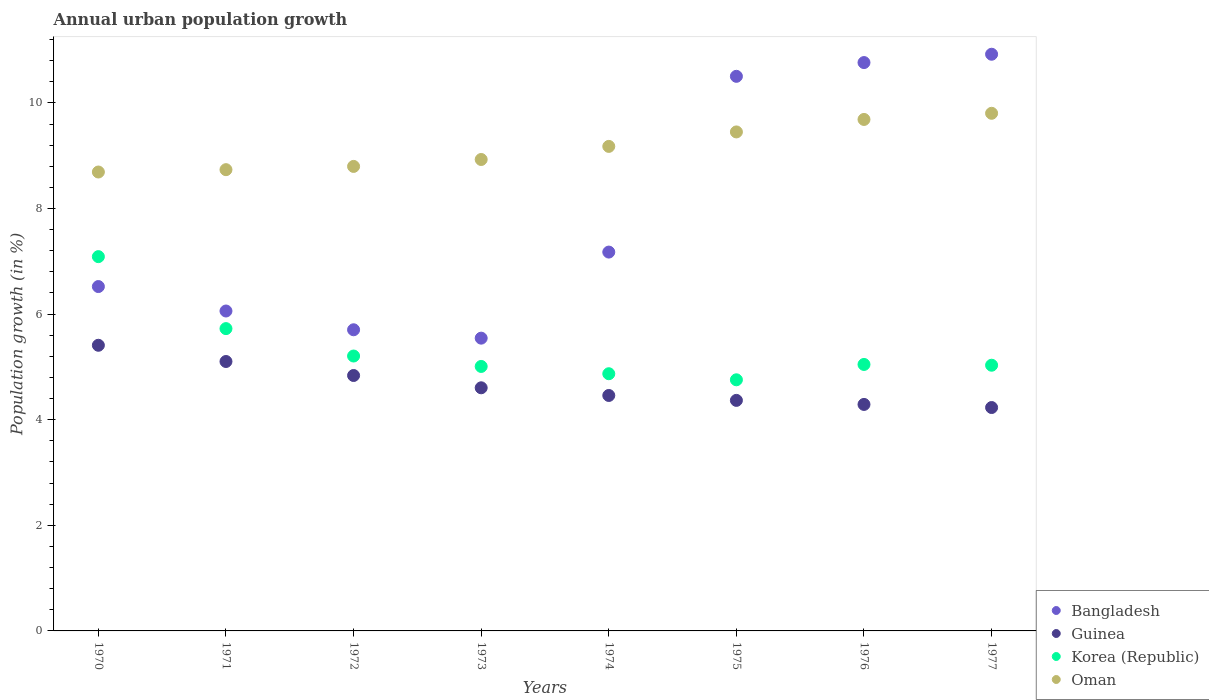Is the number of dotlines equal to the number of legend labels?
Your answer should be very brief. Yes. What is the percentage of urban population growth in Guinea in 1972?
Give a very brief answer. 4.84. Across all years, what is the maximum percentage of urban population growth in Oman?
Provide a succinct answer. 9.8. Across all years, what is the minimum percentage of urban population growth in Oman?
Your answer should be compact. 8.69. In which year was the percentage of urban population growth in Oman minimum?
Provide a short and direct response. 1970. What is the total percentage of urban population growth in Korea (Republic) in the graph?
Provide a short and direct response. 42.73. What is the difference between the percentage of urban population growth in Korea (Republic) in 1973 and that in 1974?
Make the answer very short. 0.14. What is the difference between the percentage of urban population growth in Guinea in 1972 and the percentage of urban population growth in Oman in 1974?
Your response must be concise. -4.34. What is the average percentage of urban population growth in Oman per year?
Keep it short and to the point. 9.16. In the year 1971, what is the difference between the percentage of urban population growth in Guinea and percentage of urban population growth in Bangladesh?
Ensure brevity in your answer.  -0.96. What is the ratio of the percentage of urban population growth in Bangladesh in 1976 to that in 1977?
Provide a short and direct response. 0.99. Is the percentage of urban population growth in Korea (Republic) in 1970 less than that in 1973?
Offer a very short reply. No. What is the difference between the highest and the second highest percentage of urban population growth in Bangladesh?
Give a very brief answer. 0.16. What is the difference between the highest and the lowest percentage of urban population growth in Guinea?
Keep it short and to the point. 1.18. How many dotlines are there?
Offer a very short reply. 4. How many years are there in the graph?
Provide a short and direct response. 8. Does the graph contain grids?
Ensure brevity in your answer.  No. Where does the legend appear in the graph?
Provide a succinct answer. Bottom right. How many legend labels are there?
Your answer should be compact. 4. How are the legend labels stacked?
Offer a very short reply. Vertical. What is the title of the graph?
Offer a terse response. Annual urban population growth. What is the label or title of the X-axis?
Offer a terse response. Years. What is the label or title of the Y-axis?
Give a very brief answer. Population growth (in %). What is the Population growth (in %) in Bangladesh in 1970?
Provide a succinct answer. 6.52. What is the Population growth (in %) of Guinea in 1970?
Provide a succinct answer. 5.41. What is the Population growth (in %) in Korea (Republic) in 1970?
Offer a very short reply. 7.09. What is the Population growth (in %) of Oman in 1970?
Make the answer very short. 8.69. What is the Population growth (in %) of Bangladesh in 1971?
Keep it short and to the point. 6.06. What is the Population growth (in %) in Guinea in 1971?
Ensure brevity in your answer.  5.1. What is the Population growth (in %) in Korea (Republic) in 1971?
Provide a succinct answer. 5.73. What is the Population growth (in %) of Oman in 1971?
Your response must be concise. 8.74. What is the Population growth (in %) in Bangladesh in 1972?
Make the answer very short. 5.7. What is the Population growth (in %) in Guinea in 1972?
Give a very brief answer. 4.84. What is the Population growth (in %) of Korea (Republic) in 1972?
Make the answer very short. 5.21. What is the Population growth (in %) in Oman in 1972?
Offer a terse response. 8.8. What is the Population growth (in %) of Bangladesh in 1973?
Provide a succinct answer. 5.54. What is the Population growth (in %) of Guinea in 1973?
Provide a short and direct response. 4.6. What is the Population growth (in %) in Korea (Republic) in 1973?
Make the answer very short. 5.01. What is the Population growth (in %) of Oman in 1973?
Keep it short and to the point. 8.93. What is the Population growth (in %) of Bangladesh in 1974?
Provide a short and direct response. 7.17. What is the Population growth (in %) of Guinea in 1974?
Provide a succinct answer. 4.46. What is the Population growth (in %) in Korea (Republic) in 1974?
Provide a short and direct response. 4.87. What is the Population growth (in %) in Oman in 1974?
Make the answer very short. 9.18. What is the Population growth (in %) of Bangladesh in 1975?
Your response must be concise. 10.5. What is the Population growth (in %) of Guinea in 1975?
Make the answer very short. 4.37. What is the Population growth (in %) in Korea (Republic) in 1975?
Ensure brevity in your answer.  4.76. What is the Population growth (in %) of Oman in 1975?
Your response must be concise. 9.45. What is the Population growth (in %) in Bangladesh in 1976?
Give a very brief answer. 10.76. What is the Population growth (in %) in Guinea in 1976?
Keep it short and to the point. 4.29. What is the Population growth (in %) in Korea (Republic) in 1976?
Give a very brief answer. 5.05. What is the Population growth (in %) of Oman in 1976?
Offer a terse response. 9.69. What is the Population growth (in %) in Bangladesh in 1977?
Your response must be concise. 10.92. What is the Population growth (in %) of Guinea in 1977?
Provide a succinct answer. 4.23. What is the Population growth (in %) in Korea (Republic) in 1977?
Offer a terse response. 5.03. What is the Population growth (in %) of Oman in 1977?
Provide a succinct answer. 9.8. Across all years, what is the maximum Population growth (in %) of Bangladesh?
Your answer should be compact. 10.92. Across all years, what is the maximum Population growth (in %) in Guinea?
Provide a short and direct response. 5.41. Across all years, what is the maximum Population growth (in %) in Korea (Republic)?
Offer a terse response. 7.09. Across all years, what is the maximum Population growth (in %) of Oman?
Offer a very short reply. 9.8. Across all years, what is the minimum Population growth (in %) of Bangladesh?
Your response must be concise. 5.54. Across all years, what is the minimum Population growth (in %) of Guinea?
Offer a very short reply. 4.23. Across all years, what is the minimum Population growth (in %) in Korea (Republic)?
Provide a short and direct response. 4.76. Across all years, what is the minimum Population growth (in %) of Oman?
Ensure brevity in your answer.  8.69. What is the total Population growth (in %) of Bangladesh in the graph?
Give a very brief answer. 63.19. What is the total Population growth (in %) in Guinea in the graph?
Keep it short and to the point. 37.3. What is the total Population growth (in %) in Korea (Republic) in the graph?
Provide a short and direct response. 42.73. What is the total Population growth (in %) of Oman in the graph?
Your answer should be very brief. 73.27. What is the difference between the Population growth (in %) in Bangladesh in 1970 and that in 1971?
Give a very brief answer. 0.46. What is the difference between the Population growth (in %) of Guinea in 1970 and that in 1971?
Give a very brief answer. 0.31. What is the difference between the Population growth (in %) in Korea (Republic) in 1970 and that in 1971?
Your answer should be very brief. 1.36. What is the difference between the Population growth (in %) of Oman in 1970 and that in 1971?
Offer a terse response. -0.04. What is the difference between the Population growth (in %) in Bangladesh in 1970 and that in 1972?
Your response must be concise. 0.82. What is the difference between the Population growth (in %) in Guinea in 1970 and that in 1972?
Your response must be concise. 0.57. What is the difference between the Population growth (in %) of Korea (Republic) in 1970 and that in 1972?
Provide a short and direct response. 1.88. What is the difference between the Population growth (in %) in Oman in 1970 and that in 1972?
Your answer should be very brief. -0.11. What is the difference between the Population growth (in %) of Bangladesh in 1970 and that in 1973?
Your answer should be compact. 0.98. What is the difference between the Population growth (in %) of Guinea in 1970 and that in 1973?
Your answer should be compact. 0.81. What is the difference between the Population growth (in %) in Korea (Republic) in 1970 and that in 1973?
Ensure brevity in your answer.  2.08. What is the difference between the Population growth (in %) of Oman in 1970 and that in 1973?
Your answer should be compact. -0.24. What is the difference between the Population growth (in %) of Bangladesh in 1970 and that in 1974?
Provide a succinct answer. -0.65. What is the difference between the Population growth (in %) of Guinea in 1970 and that in 1974?
Your response must be concise. 0.95. What is the difference between the Population growth (in %) of Korea (Republic) in 1970 and that in 1974?
Make the answer very short. 2.22. What is the difference between the Population growth (in %) in Oman in 1970 and that in 1974?
Offer a very short reply. -0.49. What is the difference between the Population growth (in %) of Bangladesh in 1970 and that in 1975?
Offer a terse response. -3.98. What is the difference between the Population growth (in %) of Guinea in 1970 and that in 1975?
Your answer should be compact. 1.04. What is the difference between the Population growth (in %) of Korea (Republic) in 1970 and that in 1975?
Your answer should be compact. 2.33. What is the difference between the Population growth (in %) of Oman in 1970 and that in 1975?
Give a very brief answer. -0.76. What is the difference between the Population growth (in %) in Bangladesh in 1970 and that in 1976?
Provide a succinct answer. -4.24. What is the difference between the Population growth (in %) in Guinea in 1970 and that in 1976?
Provide a succinct answer. 1.12. What is the difference between the Population growth (in %) in Korea (Republic) in 1970 and that in 1976?
Offer a terse response. 2.04. What is the difference between the Population growth (in %) of Oman in 1970 and that in 1976?
Offer a terse response. -1. What is the difference between the Population growth (in %) in Bangladesh in 1970 and that in 1977?
Keep it short and to the point. -4.4. What is the difference between the Population growth (in %) of Guinea in 1970 and that in 1977?
Offer a terse response. 1.18. What is the difference between the Population growth (in %) in Korea (Republic) in 1970 and that in 1977?
Make the answer very short. 2.06. What is the difference between the Population growth (in %) in Oman in 1970 and that in 1977?
Offer a terse response. -1.11. What is the difference between the Population growth (in %) in Bangladesh in 1971 and that in 1972?
Keep it short and to the point. 0.36. What is the difference between the Population growth (in %) of Guinea in 1971 and that in 1972?
Provide a short and direct response. 0.27. What is the difference between the Population growth (in %) of Korea (Republic) in 1971 and that in 1972?
Ensure brevity in your answer.  0.52. What is the difference between the Population growth (in %) in Oman in 1971 and that in 1972?
Keep it short and to the point. -0.06. What is the difference between the Population growth (in %) in Bangladesh in 1971 and that in 1973?
Give a very brief answer. 0.51. What is the difference between the Population growth (in %) of Guinea in 1971 and that in 1973?
Offer a very short reply. 0.5. What is the difference between the Population growth (in %) of Korea (Republic) in 1971 and that in 1973?
Provide a succinct answer. 0.72. What is the difference between the Population growth (in %) in Oman in 1971 and that in 1973?
Offer a very short reply. -0.19. What is the difference between the Population growth (in %) of Bangladesh in 1971 and that in 1974?
Your answer should be very brief. -1.12. What is the difference between the Population growth (in %) in Guinea in 1971 and that in 1974?
Offer a terse response. 0.64. What is the difference between the Population growth (in %) of Korea (Republic) in 1971 and that in 1974?
Give a very brief answer. 0.85. What is the difference between the Population growth (in %) of Oman in 1971 and that in 1974?
Your answer should be compact. -0.44. What is the difference between the Population growth (in %) of Bangladesh in 1971 and that in 1975?
Your response must be concise. -4.44. What is the difference between the Population growth (in %) of Guinea in 1971 and that in 1975?
Offer a terse response. 0.74. What is the difference between the Population growth (in %) of Korea (Republic) in 1971 and that in 1975?
Make the answer very short. 0.97. What is the difference between the Population growth (in %) in Oman in 1971 and that in 1975?
Ensure brevity in your answer.  -0.71. What is the difference between the Population growth (in %) of Bangladesh in 1971 and that in 1976?
Give a very brief answer. -4.71. What is the difference between the Population growth (in %) in Guinea in 1971 and that in 1976?
Give a very brief answer. 0.81. What is the difference between the Population growth (in %) of Korea (Republic) in 1971 and that in 1976?
Keep it short and to the point. 0.68. What is the difference between the Population growth (in %) in Oman in 1971 and that in 1976?
Give a very brief answer. -0.95. What is the difference between the Population growth (in %) in Bangladesh in 1971 and that in 1977?
Your response must be concise. -4.86. What is the difference between the Population growth (in %) of Guinea in 1971 and that in 1977?
Offer a terse response. 0.87. What is the difference between the Population growth (in %) in Korea (Republic) in 1971 and that in 1977?
Offer a very short reply. 0.69. What is the difference between the Population growth (in %) in Oman in 1971 and that in 1977?
Keep it short and to the point. -1.07. What is the difference between the Population growth (in %) in Bangladesh in 1972 and that in 1973?
Provide a succinct answer. 0.16. What is the difference between the Population growth (in %) of Guinea in 1972 and that in 1973?
Give a very brief answer. 0.23. What is the difference between the Population growth (in %) in Korea (Republic) in 1972 and that in 1973?
Provide a succinct answer. 0.2. What is the difference between the Population growth (in %) of Oman in 1972 and that in 1973?
Ensure brevity in your answer.  -0.13. What is the difference between the Population growth (in %) of Bangladesh in 1972 and that in 1974?
Give a very brief answer. -1.47. What is the difference between the Population growth (in %) in Guinea in 1972 and that in 1974?
Give a very brief answer. 0.38. What is the difference between the Population growth (in %) in Korea (Republic) in 1972 and that in 1974?
Your answer should be compact. 0.34. What is the difference between the Population growth (in %) of Oman in 1972 and that in 1974?
Give a very brief answer. -0.38. What is the difference between the Population growth (in %) in Bangladesh in 1972 and that in 1975?
Offer a terse response. -4.8. What is the difference between the Population growth (in %) in Guinea in 1972 and that in 1975?
Offer a very short reply. 0.47. What is the difference between the Population growth (in %) of Korea (Republic) in 1972 and that in 1975?
Keep it short and to the point. 0.45. What is the difference between the Population growth (in %) in Oman in 1972 and that in 1975?
Your response must be concise. -0.65. What is the difference between the Population growth (in %) of Bangladesh in 1972 and that in 1976?
Offer a terse response. -5.06. What is the difference between the Population growth (in %) in Guinea in 1972 and that in 1976?
Offer a very short reply. 0.55. What is the difference between the Population growth (in %) in Korea (Republic) in 1972 and that in 1976?
Offer a very short reply. 0.16. What is the difference between the Population growth (in %) of Oman in 1972 and that in 1976?
Your answer should be compact. -0.89. What is the difference between the Population growth (in %) in Bangladesh in 1972 and that in 1977?
Keep it short and to the point. -5.22. What is the difference between the Population growth (in %) in Guinea in 1972 and that in 1977?
Your answer should be compact. 0.61. What is the difference between the Population growth (in %) of Korea (Republic) in 1972 and that in 1977?
Provide a succinct answer. 0.17. What is the difference between the Population growth (in %) of Oman in 1972 and that in 1977?
Your answer should be very brief. -1.01. What is the difference between the Population growth (in %) in Bangladesh in 1973 and that in 1974?
Keep it short and to the point. -1.63. What is the difference between the Population growth (in %) in Guinea in 1973 and that in 1974?
Give a very brief answer. 0.15. What is the difference between the Population growth (in %) in Korea (Republic) in 1973 and that in 1974?
Ensure brevity in your answer.  0.14. What is the difference between the Population growth (in %) of Oman in 1973 and that in 1974?
Offer a terse response. -0.25. What is the difference between the Population growth (in %) in Bangladesh in 1973 and that in 1975?
Make the answer very short. -4.96. What is the difference between the Population growth (in %) of Guinea in 1973 and that in 1975?
Provide a succinct answer. 0.24. What is the difference between the Population growth (in %) of Korea (Republic) in 1973 and that in 1975?
Provide a succinct answer. 0.25. What is the difference between the Population growth (in %) of Oman in 1973 and that in 1975?
Offer a terse response. -0.52. What is the difference between the Population growth (in %) of Bangladesh in 1973 and that in 1976?
Make the answer very short. -5.22. What is the difference between the Population growth (in %) in Guinea in 1973 and that in 1976?
Provide a short and direct response. 0.32. What is the difference between the Population growth (in %) in Korea (Republic) in 1973 and that in 1976?
Provide a succinct answer. -0.04. What is the difference between the Population growth (in %) in Oman in 1973 and that in 1976?
Give a very brief answer. -0.76. What is the difference between the Population growth (in %) of Bangladesh in 1973 and that in 1977?
Your answer should be compact. -5.38. What is the difference between the Population growth (in %) of Guinea in 1973 and that in 1977?
Offer a terse response. 0.37. What is the difference between the Population growth (in %) of Korea (Republic) in 1973 and that in 1977?
Offer a terse response. -0.02. What is the difference between the Population growth (in %) of Oman in 1973 and that in 1977?
Provide a short and direct response. -0.87. What is the difference between the Population growth (in %) in Bangladesh in 1974 and that in 1975?
Your answer should be compact. -3.33. What is the difference between the Population growth (in %) of Guinea in 1974 and that in 1975?
Ensure brevity in your answer.  0.09. What is the difference between the Population growth (in %) of Korea (Republic) in 1974 and that in 1975?
Give a very brief answer. 0.11. What is the difference between the Population growth (in %) of Oman in 1974 and that in 1975?
Offer a terse response. -0.27. What is the difference between the Population growth (in %) of Bangladesh in 1974 and that in 1976?
Make the answer very short. -3.59. What is the difference between the Population growth (in %) of Guinea in 1974 and that in 1976?
Your answer should be compact. 0.17. What is the difference between the Population growth (in %) of Korea (Republic) in 1974 and that in 1976?
Offer a terse response. -0.18. What is the difference between the Population growth (in %) of Oman in 1974 and that in 1976?
Provide a short and direct response. -0.51. What is the difference between the Population growth (in %) in Bangladesh in 1974 and that in 1977?
Provide a succinct answer. -3.75. What is the difference between the Population growth (in %) of Guinea in 1974 and that in 1977?
Provide a succinct answer. 0.23. What is the difference between the Population growth (in %) in Korea (Republic) in 1974 and that in 1977?
Offer a very short reply. -0.16. What is the difference between the Population growth (in %) in Oman in 1974 and that in 1977?
Your answer should be compact. -0.63. What is the difference between the Population growth (in %) in Bangladesh in 1975 and that in 1976?
Ensure brevity in your answer.  -0.26. What is the difference between the Population growth (in %) in Guinea in 1975 and that in 1976?
Keep it short and to the point. 0.08. What is the difference between the Population growth (in %) of Korea (Republic) in 1975 and that in 1976?
Make the answer very short. -0.29. What is the difference between the Population growth (in %) in Oman in 1975 and that in 1976?
Your answer should be very brief. -0.24. What is the difference between the Population growth (in %) in Bangladesh in 1975 and that in 1977?
Your answer should be compact. -0.42. What is the difference between the Population growth (in %) in Guinea in 1975 and that in 1977?
Provide a succinct answer. 0.14. What is the difference between the Population growth (in %) of Korea (Republic) in 1975 and that in 1977?
Make the answer very short. -0.28. What is the difference between the Population growth (in %) in Oman in 1975 and that in 1977?
Your answer should be very brief. -0.35. What is the difference between the Population growth (in %) in Bangladesh in 1976 and that in 1977?
Offer a very short reply. -0.16. What is the difference between the Population growth (in %) in Guinea in 1976 and that in 1977?
Ensure brevity in your answer.  0.06. What is the difference between the Population growth (in %) of Korea (Republic) in 1976 and that in 1977?
Your response must be concise. 0.01. What is the difference between the Population growth (in %) of Oman in 1976 and that in 1977?
Offer a terse response. -0.12. What is the difference between the Population growth (in %) in Bangladesh in 1970 and the Population growth (in %) in Guinea in 1971?
Your answer should be very brief. 1.42. What is the difference between the Population growth (in %) in Bangladesh in 1970 and the Population growth (in %) in Korea (Republic) in 1971?
Your answer should be compact. 0.8. What is the difference between the Population growth (in %) in Bangladesh in 1970 and the Population growth (in %) in Oman in 1971?
Give a very brief answer. -2.21. What is the difference between the Population growth (in %) in Guinea in 1970 and the Population growth (in %) in Korea (Republic) in 1971?
Make the answer very short. -0.32. What is the difference between the Population growth (in %) in Guinea in 1970 and the Population growth (in %) in Oman in 1971?
Provide a succinct answer. -3.33. What is the difference between the Population growth (in %) of Korea (Republic) in 1970 and the Population growth (in %) of Oman in 1971?
Keep it short and to the point. -1.65. What is the difference between the Population growth (in %) of Bangladesh in 1970 and the Population growth (in %) of Guinea in 1972?
Your response must be concise. 1.68. What is the difference between the Population growth (in %) in Bangladesh in 1970 and the Population growth (in %) in Korea (Republic) in 1972?
Provide a short and direct response. 1.32. What is the difference between the Population growth (in %) in Bangladesh in 1970 and the Population growth (in %) in Oman in 1972?
Provide a succinct answer. -2.28. What is the difference between the Population growth (in %) in Guinea in 1970 and the Population growth (in %) in Korea (Republic) in 1972?
Provide a short and direct response. 0.2. What is the difference between the Population growth (in %) in Guinea in 1970 and the Population growth (in %) in Oman in 1972?
Your answer should be very brief. -3.39. What is the difference between the Population growth (in %) in Korea (Republic) in 1970 and the Population growth (in %) in Oman in 1972?
Offer a terse response. -1.71. What is the difference between the Population growth (in %) in Bangladesh in 1970 and the Population growth (in %) in Guinea in 1973?
Make the answer very short. 1.92. What is the difference between the Population growth (in %) of Bangladesh in 1970 and the Population growth (in %) of Korea (Republic) in 1973?
Make the answer very short. 1.51. What is the difference between the Population growth (in %) in Bangladesh in 1970 and the Population growth (in %) in Oman in 1973?
Your response must be concise. -2.41. What is the difference between the Population growth (in %) of Guinea in 1970 and the Population growth (in %) of Korea (Republic) in 1973?
Offer a very short reply. 0.4. What is the difference between the Population growth (in %) in Guinea in 1970 and the Population growth (in %) in Oman in 1973?
Your answer should be compact. -3.52. What is the difference between the Population growth (in %) in Korea (Republic) in 1970 and the Population growth (in %) in Oman in 1973?
Provide a succinct answer. -1.84. What is the difference between the Population growth (in %) in Bangladesh in 1970 and the Population growth (in %) in Guinea in 1974?
Keep it short and to the point. 2.06. What is the difference between the Population growth (in %) of Bangladesh in 1970 and the Population growth (in %) of Korea (Republic) in 1974?
Offer a very short reply. 1.65. What is the difference between the Population growth (in %) in Bangladesh in 1970 and the Population growth (in %) in Oman in 1974?
Offer a very short reply. -2.65. What is the difference between the Population growth (in %) of Guinea in 1970 and the Population growth (in %) of Korea (Republic) in 1974?
Your response must be concise. 0.54. What is the difference between the Population growth (in %) in Guinea in 1970 and the Population growth (in %) in Oman in 1974?
Provide a succinct answer. -3.77. What is the difference between the Population growth (in %) of Korea (Republic) in 1970 and the Population growth (in %) of Oman in 1974?
Offer a terse response. -2.09. What is the difference between the Population growth (in %) in Bangladesh in 1970 and the Population growth (in %) in Guinea in 1975?
Ensure brevity in your answer.  2.16. What is the difference between the Population growth (in %) in Bangladesh in 1970 and the Population growth (in %) in Korea (Republic) in 1975?
Provide a short and direct response. 1.77. What is the difference between the Population growth (in %) in Bangladesh in 1970 and the Population growth (in %) in Oman in 1975?
Give a very brief answer. -2.93. What is the difference between the Population growth (in %) of Guinea in 1970 and the Population growth (in %) of Korea (Republic) in 1975?
Offer a terse response. 0.65. What is the difference between the Population growth (in %) in Guinea in 1970 and the Population growth (in %) in Oman in 1975?
Offer a very short reply. -4.04. What is the difference between the Population growth (in %) of Korea (Republic) in 1970 and the Population growth (in %) of Oman in 1975?
Offer a terse response. -2.36. What is the difference between the Population growth (in %) in Bangladesh in 1970 and the Population growth (in %) in Guinea in 1976?
Provide a succinct answer. 2.23. What is the difference between the Population growth (in %) of Bangladesh in 1970 and the Population growth (in %) of Korea (Republic) in 1976?
Your answer should be very brief. 1.48. What is the difference between the Population growth (in %) of Bangladesh in 1970 and the Population growth (in %) of Oman in 1976?
Your answer should be very brief. -3.16. What is the difference between the Population growth (in %) in Guinea in 1970 and the Population growth (in %) in Korea (Republic) in 1976?
Offer a very short reply. 0.36. What is the difference between the Population growth (in %) in Guinea in 1970 and the Population growth (in %) in Oman in 1976?
Your response must be concise. -4.28. What is the difference between the Population growth (in %) of Korea (Republic) in 1970 and the Population growth (in %) of Oman in 1976?
Give a very brief answer. -2.6. What is the difference between the Population growth (in %) of Bangladesh in 1970 and the Population growth (in %) of Guinea in 1977?
Your answer should be very brief. 2.29. What is the difference between the Population growth (in %) in Bangladesh in 1970 and the Population growth (in %) in Korea (Republic) in 1977?
Your response must be concise. 1.49. What is the difference between the Population growth (in %) of Bangladesh in 1970 and the Population growth (in %) of Oman in 1977?
Keep it short and to the point. -3.28. What is the difference between the Population growth (in %) in Guinea in 1970 and the Population growth (in %) in Korea (Republic) in 1977?
Offer a very short reply. 0.38. What is the difference between the Population growth (in %) in Guinea in 1970 and the Population growth (in %) in Oman in 1977?
Provide a short and direct response. -4.39. What is the difference between the Population growth (in %) of Korea (Republic) in 1970 and the Population growth (in %) of Oman in 1977?
Offer a very short reply. -2.71. What is the difference between the Population growth (in %) of Bangladesh in 1971 and the Population growth (in %) of Guinea in 1972?
Offer a terse response. 1.22. What is the difference between the Population growth (in %) of Bangladesh in 1971 and the Population growth (in %) of Korea (Republic) in 1972?
Keep it short and to the point. 0.85. What is the difference between the Population growth (in %) of Bangladesh in 1971 and the Population growth (in %) of Oman in 1972?
Provide a short and direct response. -2.74. What is the difference between the Population growth (in %) of Guinea in 1971 and the Population growth (in %) of Korea (Republic) in 1972?
Give a very brief answer. -0.1. What is the difference between the Population growth (in %) of Guinea in 1971 and the Population growth (in %) of Oman in 1972?
Your answer should be compact. -3.69. What is the difference between the Population growth (in %) in Korea (Republic) in 1971 and the Population growth (in %) in Oman in 1972?
Offer a very short reply. -3.07. What is the difference between the Population growth (in %) in Bangladesh in 1971 and the Population growth (in %) in Guinea in 1973?
Your answer should be compact. 1.45. What is the difference between the Population growth (in %) in Bangladesh in 1971 and the Population growth (in %) in Korea (Republic) in 1973?
Make the answer very short. 1.05. What is the difference between the Population growth (in %) in Bangladesh in 1971 and the Population growth (in %) in Oman in 1973?
Ensure brevity in your answer.  -2.87. What is the difference between the Population growth (in %) in Guinea in 1971 and the Population growth (in %) in Korea (Republic) in 1973?
Offer a very short reply. 0.09. What is the difference between the Population growth (in %) in Guinea in 1971 and the Population growth (in %) in Oman in 1973?
Keep it short and to the point. -3.83. What is the difference between the Population growth (in %) in Korea (Republic) in 1971 and the Population growth (in %) in Oman in 1973?
Make the answer very short. -3.2. What is the difference between the Population growth (in %) in Bangladesh in 1971 and the Population growth (in %) in Guinea in 1974?
Provide a short and direct response. 1.6. What is the difference between the Population growth (in %) in Bangladesh in 1971 and the Population growth (in %) in Korea (Republic) in 1974?
Offer a very short reply. 1.19. What is the difference between the Population growth (in %) of Bangladesh in 1971 and the Population growth (in %) of Oman in 1974?
Make the answer very short. -3.12. What is the difference between the Population growth (in %) in Guinea in 1971 and the Population growth (in %) in Korea (Republic) in 1974?
Ensure brevity in your answer.  0.23. What is the difference between the Population growth (in %) of Guinea in 1971 and the Population growth (in %) of Oman in 1974?
Provide a succinct answer. -4.07. What is the difference between the Population growth (in %) of Korea (Republic) in 1971 and the Population growth (in %) of Oman in 1974?
Offer a terse response. -3.45. What is the difference between the Population growth (in %) in Bangladesh in 1971 and the Population growth (in %) in Guinea in 1975?
Your answer should be very brief. 1.69. What is the difference between the Population growth (in %) of Bangladesh in 1971 and the Population growth (in %) of Korea (Republic) in 1975?
Give a very brief answer. 1.3. What is the difference between the Population growth (in %) in Bangladesh in 1971 and the Population growth (in %) in Oman in 1975?
Ensure brevity in your answer.  -3.39. What is the difference between the Population growth (in %) of Guinea in 1971 and the Population growth (in %) of Korea (Republic) in 1975?
Provide a short and direct response. 0.35. What is the difference between the Population growth (in %) of Guinea in 1971 and the Population growth (in %) of Oman in 1975?
Your answer should be compact. -4.35. What is the difference between the Population growth (in %) of Korea (Republic) in 1971 and the Population growth (in %) of Oman in 1975?
Provide a succinct answer. -3.72. What is the difference between the Population growth (in %) in Bangladesh in 1971 and the Population growth (in %) in Guinea in 1976?
Make the answer very short. 1.77. What is the difference between the Population growth (in %) in Bangladesh in 1971 and the Population growth (in %) in Korea (Republic) in 1976?
Offer a very short reply. 1.01. What is the difference between the Population growth (in %) of Bangladesh in 1971 and the Population growth (in %) of Oman in 1976?
Provide a succinct answer. -3.63. What is the difference between the Population growth (in %) in Guinea in 1971 and the Population growth (in %) in Korea (Republic) in 1976?
Keep it short and to the point. 0.06. What is the difference between the Population growth (in %) in Guinea in 1971 and the Population growth (in %) in Oman in 1976?
Provide a short and direct response. -4.58. What is the difference between the Population growth (in %) in Korea (Republic) in 1971 and the Population growth (in %) in Oman in 1976?
Ensure brevity in your answer.  -3.96. What is the difference between the Population growth (in %) in Bangladesh in 1971 and the Population growth (in %) in Guinea in 1977?
Keep it short and to the point. 1.83. What is the difference between the Population growth (in %) of Bangladesh in 1971 and the Population growth (in %) of Korea (Republic) in 1977?
Give a very brief answer. 1.03. What is the difference between the Population growth (in %) in Bangladesh in 1971 and the Population growth (in %) in Oman in 1977?
Make the answer very short. -3.74. What is the difference between the Population growth (in %) in Guinea in 1971 and the Population growth (in %) in Korea (Republic) in 1977?
Give a very brief answer. 0.07. What is the difference between the Population growth (in %) in Guinea in 1971 and the Population growth (in %) in Oman in 1977?
Ensure brevity in your answer.  -4.7. What is the difference between the Population growth (in %) in Korea (Republic) in 1971 and the Population growth (in %) in Oman in 1977?
Offer a very short reply. -4.08. What is the difference between the Population growth (in %) in Bangladesh in 1972 and the Population growth (in %) in Guinea in 1973?
Provide a succinct answer. 1.1. What is the difference between the Population growth (in %) of Bangladesh in 1972 and the Population growth (in %) of Korea (Republic) in 1973?
Keep it short and to the point. 0.69. What is the difference between the Population growth (in %) in Bangladesh in 1972 and the Population growth (in %) in Oman in 1973?
Give a very brief answer. -3.22. What is the difference between the Population growth (in %) in Guinea in 1972 and the Population growth (in %) in Korea (Republic) in 1973?
Provide a short and direct response. -0.17. What is the difference between the Population growth (in %) in Guinea in 1972 and the Population growth (in %) in Oman in 1973?
Your answer should be compact. -4.09. What is the difference between the Population growth (in %) in Korea (Republic) in 1972 and the Population growth (in %) in Oman in 1973?
Your answer should be very brief. -3.72. What is the difference between the Population growth (in %) of Bangladesh in 1972 and the Population growth (in %) of Guinea in 1974?
Your response must be concise. 1.24. What is the difference between the Population growth (in %) in Bangladesh in 1972 and the Population growth (in %) in Korea (Republic) in 1974?
Provide a short and direct response. 0.83. What is the difference between the Population growth (in %) in Bangladesh in 1972 and the Population growth (in %) in Oman in 1974?
Keep it short and to the point. -3.47. What is the difference between the Population growth (in %) in Guinea in 1972 and the Population growth (in %) in Korea (Republic) in 1974?
Your response must be concise. -0.03. What is the difference between the Population growth (in %) of Guinea in 1972 and the Population growth (in %) of Oman in 1974?
Give a very brief answer. -4.34. What is the difference between the Population growth (in %) of Korea (Republic) in 1972 and the Population growth (in %) of Oman in 1974?
Your answer should be very brief. -3.97. What is the difference between the Population growth (in %) in Bangladesh in 1972 and the Population growth (in %) in Guinea in 1975?
Offer a very short reply. 1.34. What is the difference between the Population growth (in %) of Bangladesh in 1972 and the Population growth (in %) of Korea (Republic) in 1975?
Your answer should be compact. 0.95. What is the difference between the Population growth (in %) in Bangladesh in 1972 and the Population growth (in %) in Oman in 1975?
Your answer should be very brief. -3.75. What is the difference between the Population growth (in %) in Guinea in 1972 and the Population growth (in %) in Korea (Republic) in 1975?
Keep it short and to the point. 0.08. What is the difference between the Population growth (in %) of Guinea in 1972 and the Population growth (in %) of Oman in 1975?
Your response must be concise. -4.61. What is the difference between the Population growth (in %) in Korea (Republic) in 1972 and the Population growth (in %) in Oman in 1975?
Offer a very short reply. -4.24. What is the difference between the Population growth (in %) in Bangladesh in 1972 and the Population growth (in %) in Guinea in 1976?
Keep it short and to the point. 1.41. What is the difference between the Population growth (in %) of Bangladesh in 1972 and the Population growth (in %) of Korea (Republic) in 1976?
Your answer should be very brief. 0.66. What is the difference between the Population growth (in %) of Bangladesh in 1972 and the Population growth (in %) of Oman in 1976?
Give a very brief answer. -3.98. What is the difference between the Population growth (in %) in Guinea in 1972 and the Population growth (in %) in Korea (Republic) in 1976?
Provide a short and direct response. -0.21. What is the difference between the Population growth (in %) in Guinea in 1972 and the Population growth (in %) in Oman in 1976?
Your response must be concise. -4.85. What is the difference between the Population growth (in %) in Korea (Republic) in 1972 and the Population growth (in %) in Oman in 1976?
Ensure brevity in your answer.  -4.48. What is the difference between the Population growth (in %) in Bangladesh in 1972 and the Population growth (in %) in Guinea in 1977?
Ensure brevity in your answer.  1.47. What is the difference between the Population growth (in %) of Bangladesh in 1972 and the Population growth (in %) of Korea (Republic) in 1977?
Your response must be concise. 0.67. What is the difference between the Population growth (in %) in Bangladesh in 1972 and the Population growth (in %) in Oman in 1977?
Give a very brief answer. -4.1. What is the difference between the Population growth (in %) in Guinea in 1972 and the Population growth (in %) in Korea (Republic) in 1977?
Your answer should be compact. -0.19. What is the difference between the Population growth (in %) of Guinea in 1972 and the Population growth (in %) of Oman in 1977?
Offer a very short reply. -4.97. What is the difference between the Population growth (in %) in Korea (Republic) in 1972 and the Population growth (in %) in Oman in 1977?
Your answer should be very brief. -4.6. What is the difference between the Population growth (in %) in Bangladesh in 1973 and the Population growth (in %) in Guinea in 1974?
Your response must be concise. 1.09. What is the difference between the Population growth (in %) of Bangladesh in 1973 and the Population growth (in %) of Korea (Republic) in 1974?
Provide a short and direct response. 0.67. What is the difference between the Population growth (in %) in Bangladesh in 1973 and the Population growth (in %) in Oman in 1974?
Provide a short and direct response. -3.63. What is the difference between the Population growth (in %) in Guinea in 1973 and the Population growth (in %) in Korea (Republic) in 1974?
Provide a short and direct response. -0.27. What is the difference between the Population growth (in %) in Guinea in 1973 and the Population growth (in %) in Oman in 1974?
Make the answer very short. -4.57. What is the difference between the Population growth (in %) in Korea (Republic) in 1973 and the Population growth (in %) in Oman in 1974?
Your answer should be compact. -4.17. What is the difference between the Population growth (in %) of Bangladesh in 1973 and the Population growth (in %) of Guinea in 1975?
Make the answer very short. 1.18. What is the difference between the Population growth (in %) in Bangladesh in 1973 and the Population growth (in %) in Korea (Republic) in 1975?
Your answer should be compact. 0.79. What is the difference between the Population growth (in %) of Bangladesh in 1973 and the Population growth (in %) of Oman in 1975?
Your answer should be compact. -3.91. What is the difference between the Population growth (in %) in Guinea in 1973 and the Population growth (in %) in Korea (Republic) in 1975?
Your answer should be compact. -0.15. What is the difference between the Population growth (in %) of Guinea in 1973 and the Population growth (in %) of Oman in 1975?
Give a very brief answer. -4.85. What is the difference between the Population growth (in %) of Korea (Republic) in 1973 and the Population growth (in %) of Oman in 1975?
Provide a succinct answer. -4.44. What is the difference between the Population growth (in %) of Bangladesh in 1973 and the Population growth (in %) of Guinea in 1976?
Your answer should be very brief. 1.26. What is the difference between the Population growth (in %) in Bangladesh in 1973 and the Population growth (in %) in Korea (Republic) in 1976?
Your answer should be compact. 0.5. What is the difference between the Population growth (in %) in Bangladesh in 1973 and the Population growth (in %) in Oman in 1976?
Offer a terse response. -4.14. What is the difference between the Population growth (in %) of Guinea in 1973 and the Population growth (in %) of Korea (Republic) in 1976?
Give a very brief answer. -0.44. What is the difference between the Population growth (in %) in Guinea in 1973 and the Population growth (in %) in Oman in 1976?
Make the answer very short. -5.08. What is the difference between the Population growth (in %) of Korea (Republic) in 1973 and the Population growth (in %) of Oman in 1976?
Give a very brief answer. -4.68. What is the difference between the Population growth (in %) in Bangladesh in 1973 and the Population growth (in %) in Guinea in 1977?
Your answer should be very brief. 1.31. What is the difference between the Population growth (in %) in Bangladesh in 1973 and the Population growth (in %) in Korea (Republic) in 1977?
Give a very brief answer. 0.51. What is the difference between the Population growth (in %) of Bangladesh in 1973 and the Population growth (in %) of Oman in 1977?
Keep it short and to the point. -4.26. What is the difference between the Population growth (in %) of Guinea in 1973 and the Population growth (in %) of Korea (Republic) in 1977?
Your response must be concise. -0.43. What is the difference between the Population growth (in %) of Guinea in 1973 and the Population growth (in %) of Oman in 1977?
Keep it short and to the point. -5.2. What is the difference between the Population growth (in %) of Korea (Republic) in 1973 and the Population growth (in %) of Oman in 1977?
Offer a terse response. -4.79. What is the difference between the Population growth (in %) of Bangladesh in 1974 and the Population growth (in %) of Guinea in 1975?
Ensure brevity in your answer.  2.81. What is the difference between the Population growth (in %) in Bangladesh in 1974 and the Population growth (in %) in Korea (Republic) in 1975?
Keep it short and to the point. 2.42. What is the difference between the Population growth (in %) of Bangladesh in 1974 and the Population growth (in %) of Oman in 1975?
Give a very brief answer. -2.28. What is the difference between the Population growth (in %) of Guinea in 1974 and the Population growth (in %) of Korea (Republic) in 1975?
Keep it short and to the point. -0.3. What is the difference between the Population growth (in %) of Guinea in 1974 and the Population growth (in %) of Oman in 1975?
Offer a very short reply. -4.99. What is the difference between the Population growth (in %) of Korea (Republic) in 1974 and the Population growth (in %) of Oman in 1975?
Ensure brevity in your answer.  -4.58. What is the difference between the Population growth (in %) of Bangladesh in 1974 and the Population growth (in %) of Guinea in 1976?
Your answer should be compact. 2.89. What is the difference between the Population growth (in %) of Bangladesh in 1974 and the Population growth (in %) of Korea (Republic) in 1976?
Ensure brevity in your answer.  2.13. What is the difference between the Population growth (in %) in Bangladesh in 1974 and the Population growth (in %) in Oman in 1976?
Your response must be concise. -2.51. What is the difference between the Population growth (in %) of Guinea in 1974 and the Population growth (in %) of Korea (Republic) in 1976?
Keep it short and to the point. -0.59. What is the difference between the Population growth (in %) in Guinea in 1974 and the Population growth (in %) in Oman in 1976?
Keep it short and to the point. -5.23. What is the difference between the Population growth (in %) of Korea (Republic) in 1974 and the Population growth (in %) of Oman in 1976?
Your answer should be very brief. -4.82. What is the difference between the Population growth (in %) of Bangladesh in 1974 and the Population growth (in %) of Guinea in 1977?
Offer a very short reply. 2.94. What is the difference between the Population growth (in %) in Bangladesh in 1974 and the Population growth (in %) in Korea (Republic) in 1977?
Keep it short and to the point. 2.14. What is the difference between the Population growth (in %) in Bangladesh in 1974 and the Population growth (in %) in Oman in 1977?
Give a very brief answer. -2.63. What is the difference between the Population growth (in %) of Guinea in 1974 and the Population growth (in %) of Korea (Republic) in 1977?
Offer a very short reply. -0.57. What is the difference between the Population growth (in %) in Guinea in 1974 and the Population growth (in %) in Oman in 1977?
Give a very brief answer. -5.34. What is the difference between the Population growth (in %) in Korea (Republic) in 1974 and the Population growth (in %) in Oman in 1977?
Give a very brief answer. -4.93. What is the difference between the Population growth (in %) in Bangladesh in 1975 and the Population growth (in %) in Guinea in 1976?
Offer a terse response. 6.21. What is the difference between the Population growth (in %) in Bangladesh in 1975 and the Population growth (in %) in Korea (Republic) in 1976?
Offer a terse response. 5.46. What is the difference between the Population growth (in %) of Bangladesh in 1975 and the Population growth (in %) of Oman in 1976?
Make the answer very short. 0.82. What is the difference between the Population growth (in %) in Guinea in 1975 and the Population growth (in %) in Korea (Republic) in 1976?
Your answer should be compact. -0.68. What is the difference between the Population growth (in %) in Guinea in 1975 and the Population growth (in %) in Oman in 1976?
Your answer should be compact. -5.32. What is the difference between the Population growth (in %) of Korea (Republic) in 1975 and the Population growth (in %) of Oman in 1976?
Keep it short and to the point. -4.93. What is the difference between the Population growth (in %) in Bangladesh in 1975 and the Population growth (in %) in Guinea in 1977?
Ensure brevity in your answer.  6.27. What is the difference between the Population growth (in %) of Bangladesh in 1975 and the Population growth (in %) of Korea (Republic) in 1977?
Your answer should be very brief. 5.47. What is the difference between the Population growth (in %) of Bangladesh in 1975 and the Population growth (in %) of Oman in 1977?
Give a very brief answer. 0.7. What is the difference between the Population growth (in %) of Guinea in 1975 and the Population growth (in %) of Korea (Republic) in 1977?
Provide a succinct answer. -0.67. What is the difference between the Population growth (in %) in Guinea in 1975 and the Population growth (in %) in Oman in 1977?
Provide a short and direct response. -5.44. What is the difference between the Population growth (in %) in Korea (Republic) in 1975 and the Population growth (in %) in Oman in 1977?
Make the answer very short. -5.05. What is the difference between the Population growth (in %) of Bangladesh in 1976 and the Population growth (in %) of Guinea in 1977?
Offer a terse response. 6.53. What is the difference between the Population growth (in %) in Bangladesh in 1976 and the Population growth (in %) in Korea (Republic) in 1977?
Provide a succinct answer. 5.73. What is the difference between the Population growth (in %) of Bangladesh in 1976 and the Population growth (in %) of Oman in 1977?
Ensure brevity in your answer.  0.96. What is the difference between the Population growth (in %) of Guinea in 1976 and the Population growth (in %) of Korea (Republic) in 1977?
Your answer should be compact. -0.74. What is the difference between the Population growth (in %) of Guinea in 1976 and the Population growth (in %) of Oman in 1977?
Your answer should be compact. -5.51. What is the difference between the Population growth (in %) of Korea (Republic) in 1976 and the Population growth (in %) of Oman in 1977?
Provide a succinct answer. -4.76. What is the average Population growth (in %) of Bangladesh per year?
Provide a short and direct response. 7.9. What is the average Population growth (in %) of Guinea per year?
Ensure brevity in your answer.  4.66. What is the average Population growth (in %) in Korea (Republic) per year?
Make the answer very short. 5.34. What is the average Population growth (in %) of Oman per year?
Offer a terse response. 9.16. In the year 1970, what is the difference between the Population growth (in %) of Bangladesh and Population growth (in %) of Guinea?
Your answer should be very brief. 1.11. In the year 1970, what is the difference between the Population growth (in %) in Bangladesh and Population growth (in %) in Korea (Republic)?
Your answer should be compact. -0.57. In the year 1970, what is the difference between the Population growth (in %) in Bangladesh and Population growth (in %) in Oman?
Your response must be concise. -2.17. In the year 1970, what is the difference between the Population growth (in %) in Guinea and Population growth (in %) in Korea (Republic)?
Ensure brevity in your answer.  -1.68. In the year 1970, what is the difference between the Population growth (in %) of Guinea and Population growth (in %) of Oman?
Your answer should be compact. -3.28. In the year 1970, what is the difference between the Population growth (in %) in Korea (Republic) and Population growth (in %) in Oman?
Offer a terse response. -1.6. In the year 1971, what is the difference between the Population growth (in %) in Bangladesh and Population growth (in %) in Guinea?
Offer a terse response. 0.96. In the year 1971, what is the difference between the Population growth (in %) in Bangladesh and Population growth (in %) in Korea (Republic)?
Keep it short and to the point. 0.33. In the year 1971, what is the difference between the Population growth (in %) in Bangladesh and Population growth (in %) in Oman?
Provide a short and direct response. -2.68. In the year 1971, what is the difference between the Population growth (in %) in Guinea and Population growth (in %) in Korea (Republic)?
Offer a very short reply. -0.62. In the year 1971, what is the difference between the Population growth (in %) of Guinea and Population growth (in %) of Oman?
Provide a short and direct response. -3.63. In the year 1971, what is the difference between the Population growth (in %) of Korea (Republic) and Population growth (in %) of Oman?
Your response must be concise. -3.01. In the year 1972, what is the difference between the Population growth (in %) in Bangladesh and Population growth (in %) in Guinea?
Give a very brief answer. 0.87. In the year 1972, what is the difference between the Population growth (in %) in Bangladesh and Population growth (in %) in Korea (Republic)?
Offer a terse response. 0.5. In the year 1972, what is the difference between the Population growth (in %) in Bangladesh and Population growth (in %) in Oman?
Make the answer very short. -3.09. In the year 1972, what is the difference between the Population growth (in %) of Guinea and Population growth (in %) of Korea (Republic)?
Ensure brevity in your answer.  -0.37. In the year 1972, what is the difference between the Population growth (in %) of Guinea and Population growth (in %) of Oman?
Offer a terse response. -3.96. In the year 1972, what is the difference between the Population growth (in %) of Korea (Republic) and Population growth (in %) of Oman?
Offer a terse response. -3.59. In the year 1973, what is the difference between the Population growth (in %) in Bangladesh and Population growth (in %) in Guinea?
Make the answer very short. 0.94. In the year 1973, what is the difference between the Population growth (in %) in Bangladesh and Population growth (in %) in Korea (Republic)?
Your answer should be compact. 0.54. In the year 1973, what is the difference between the Population growth (in %) of Bangladesh and Population growth (in %) of Oman?
Ensure brevity in your answer.  -3.38. In the year 1973, what is the difference between the Population growth (in %) of Guinea and Population growth (in %) of Korea (Republic)?
Offer a terse response. -0.4. In the year 1973, what is the difference between the Population growth (in %) in Guinea and Population growth (in %) in Oman?
Ensure brevity in your answer.  -4.32. In the year 1973, what is the difference between the Population growth (in %) of Korea (Republic) and Population growth (in %) of Oman?
Your response must be concise. -3.92. In the year 1974, what is the difference between the Population growth (in %) of Bangladesh and Population growth (in %) of Guinea?
Your response must be concise. 2.72. In the year 1974, what is the difference between the Population growth (in %) in Bangladesh and Population growth (in %) in Korea (Republic)?
Provide a short and direct response. 2.3. In the year 1974, what is the difference between the Population growth (in %) in Bangladesh and Population growth (in %) in Oman?
Your answer should be very brief. -2. In the year 1974, what is the difference between the Population growth (in %) of Guinea and Population growth (in %) of Korea (Republic)?
Make the answer very short. -0.41. In the year 1974, what is the difference between the Population growth (in %) of Guinea and Population growth (in %) of Oman?
Make the answer very short. -4.72. In the year 1974, what is the difference between the Population growth (in %) in Korea (Republic) and Population growth (in %) in Oman?
Your answer should be very brief. -4.31. In the year 1975, what is the difference between the Population growth (in %) of Bangladesh and Population growth (in %) of Guinea?
Your answer should be very brief. 6.14. In the year 1975, what is the difference between the Population growth (in %) of Bangladesh and Population growth (in %) of Korea (Republic)?
Make the answer very short. 5.75. In the year 1975, what is the difference between the Population growth (in %) of Bangladesh and Population growth (in %) of Oman?
Your answer should be compact. 1.05. In the year 1975, what is the difference between the Population growth (in %) in Guinea and Population growth (in %) in Korea (Republic)?
Provide a succinct answer. -0.39. In the year 1975, what is the difference between the Population growth (in %) of Guinea and Population growth (in %) of Oman?
Provide a succinct answer. -5.08. In the year 1975, what is the difference between the Population growth (in %) in Korea (Republic) and Population growth (in %) in Oman?
Your answer should be very brief. -4.69. In the year 1976, what is the difference between the Population growth (in %) in Bangladesh and Population growth (in %) in Guinea?
Ensure brevity in your answer.  6.47. In the year 1976, what is the difference between the Population growth (in %) in Bangladesh and Population growth (in %) in Korea (Republic)?
Your response must be concise. 5.72. In the year 1976, what is the difference between the Population growth (in %) in Bangladesh and Population growth (in %) in Oman?
Keep it short and to the point. 1.08. In the year 1976, what is the difference between the Population growth (in %) of Guinea and Population growth (in %) of Korea (Republic)?
Your answer should be very brief. -0.76. In the year 1976, what is the difference between the Population growth (in %) in Guinea and Population growth (in %) in Oman?
Give a very brief answer. -5.4. In the year 1976, what is the difference between the Population growth (in %) in Korea (Republic) and Population growth (in %) in Oman?
Your answer should be very brief. -4.64. In the year 1977, what is the difference between the Population growth (in %) of Bangladesh and Population growth (in %) of Guinea?
Provide a succinct answer. 6.69. In the year 1977, what is the difference between the Population growth (in %) of Bangladesh and Population growth (in %) of Korea (Republic)?
Your answer should be very brief. 5.89. In the year 1977, what is the difference between the Population growth (in %) in Bangladesh and Population growth (in %) in Oman?
Ensure brevity in your answer.  1.12. In the year 1977, what is the difference between the Population growth (in %) in Guinea and Population growth (in %) in Korea (Republic)?
Give a very brief answer. -0.8. In the year 1977, what is the difference between the Population growth (in %) of Guinea and Population growth (in %) of Oman?
Offer a terse response. -5.57. In the year 1977, what is the difference between the Population growth (in %) of Korea (Republic) and Population growth (in %) of Oman?
Offer a very short reply. -4.77. What is the ratio of the Population growth (in %) in Bangladesh in 1970 to that in 1971?
Ensure brevity in your answer.  1.08. What is the ratio of the Population growth (in %) in Guinea in 1970 to that in 1971?
Offer a very short reply. 1.06. What is the ratio of the Population growth (in %) in Korea (Republic) in 1970 to that in 1971?
Your response must be concise. 1.24. What is the ratio of the Population growth (in %) in Bangladesh in 1970 to that in 1972?
Offer a terse response. 1.14. What is the ratio of the Population growth (in %) in Guinea in 1970 to that in 1972?
Make the answer very short. 1.12. What is the ratio of the Population growth (in %) of Korea (Republic) in 1970 to that in 1972?
Offer a terse response. 1.36. What is the ratio of the Population growth (in %) in Oman in 1970 to that in 1972?
Keep it short and to the point. 0.99. What is the ratio of the Population growth (in %) in Bangladesh in 1970 to that in 1973?
Provide a succinct answer. 1.18. What is the ratio of the Population growth (in %) of Guinea in 1970 to that in 1973?
Offer a terse response. 1.17. What is the ratio of the Population growth (in %) of Korea (Republic) in 1970 to that in 1973?
Provide a succinct answer. 1.42. What is the ratio of the Population growth (in %) of Oman in 1970 to that in 1973?
Your answer should be compact. 0.97. What is the ratio of the Population growth (in %) of Bangladesh in 1970 to that in 1974?
Give a very brief answer. 0.91. What is the ratio of the Population growth (in %) in Guinea in 1970 to that in 1974?
Provide a short and direct response. 1.21. What is the ratio of the Population growth (in %) of Korea (Republic) in 1970 to that in 1974?
Provide a short and direct response. 1.46. What is the ratio of the Population growth (in %) of Oman in 1970 to that in 1974?
Ensure brevity in your answer.  0.95. What is the ratio of the Population growth (in %) of Bangladesh in 1970 to that in 1975?
Your answer should be very brief. 0.62. What is the ratio of the Population growth (in %) in Guinea in 1970 to that in 1975?
Your answer should be very brief. 1.24. What is the ratio of the Population growth (in %) of Korea (Republic) in 1970 to that in 1975?
Provide a succinct answer. 1.49. What is the ratio of the Population growth (in %) of Oman in 1970 to that in 1975?
Your answer should be very brief. 0.92. What is the ratio of the Population growth (in %) in Bangladesh in 1970 to that in 1976?
Provide a succinct answer. 0.61. What is the ratio of the Population growth (in %) in Guinea in 1970 to that in 1976?
Offer a terse response. 1.26. What is the ratio of the Population growth (in %) in Korea (Republic) in 1970 to that in 1976?
Your response must be concise. 1.4. What is the ratio of the Population growth (in %) in Oman in 1970 to that in 1976?
Offer a very short reply. 0.9. What is the ratio of the Population growth (in %) of Bangladesh in 1970 to that in 1977?
Offer a very short reply. 0.6. What is the ratio of the Population growth (in %) of Guinea in 1970 to that in 1977?
Offer a terse response. 1.28. What is the ratio of the Population growth (in %) in Korea (Republic) in 1970 to that in 1977?
Ensure brevity in your answer.  1.41. What is the ratio of the Population growth (in %) in Oman in 1970 to that in 1977?
Make the answer very short. 0.89. What is the ratio of the Population growth (in %) of Bangladesh in 1971 to that in 1972?
Provide a short and direct response. 1.06. What is the ratio of the Population growth (in %) in Guinea in 1971 to that in 1972?
Give a very brief answer. 1.05. What is the ratio of the Population growth (in %) of Korea (Republic) in 1971 to that in 1972?
Your answer should be compact. 1.1. What is the ratio of the Population growth (in %) of Oman in 1971 to that in 1972?
Make the answer very short. 0.99. What is the ratio of the Population growth (in %) of Bangladesh in 1971 to that in 1973?
Your response must be concise. 1.09. What is the ratio of the Population growth (in %) of Guinea in 1971 to that in 1973?
Ensure brevity in your answer.  1.11. What is the ratio of the Population growth (in %) of Korea (Republic) in 1971 to that in 1973?
Offer a terse response. 1.14. What is the ratio of the Population growth (in %) of Oman in 1971 to that in 1973?
Give a very brief answer. 0.98. What is the ratio of the Population growth (in %) of Bangladesh in 1971 to that in 1974?
Provide a short and direct response. 0.84. What is the ratio of the Population growth (in %) of Guinea in 1971 to that in 1974?
Offer a terse response. 1.14. What is the ratio of the Population growth (in %) in Korea (Republic) in 1971 to that in 1974?
Offer a terse response. 1.18. What is the ratio of the Population growth (in %) in Bangladesh in 1971 to that in 1975?
Offer a terse response. 0.58. What is the ratio of the Population growth (in %) of Guinea in 1971 to that in 1975?
Your answer should be compact. 1.17. What is the ratio of the Population growth (in %) of Korea (Republic) in 1971 to that in 1975?
Keep it short and to the point. 1.2. What is the ratio of the Population growth (in %) in Oman in 1971 to that in 1975?
Provide a short and direct response. 0.92. What is the ratio of the Population growth (in %) in Bangladesh in 1971 to that in 1976?
Make the answer very short. 0.56. What is the ratio of the Population growth (in %) in Guinea in 1971 to that in 1976?
Your answer should be compact. 1.19. What is the ratio of the Population growth (in %) in Korea (Republic) in 1971 to that in 1976?
Your response must be concise. 1.13. What is the ratio of the Population growth (in %) of Oman in 1971 to that in 1976?
Give a very brief answer. 0.9. What is the ratio of the Population growth (in %) of Bangladesh in 1971 to that in 1977?
Offer a terse response. 0.55. What is the ratio of the Population growth (in %) in Guinea in 1971 to that in 1977?
Your answer should be compact. 1.21. What is the ratio of the Population growth (in %) in Korea (Republic) in 1971 to that in 1977?
Your response must be concise. 1.14. What is the ratio of the Population growth (in %) of Oman in 1971 to that in 1977?
Keep it short and to the point. 0.89. What is the ratio of the Population growth (in %) of Bangladesh in 1972 to that in 1973?
Provide a succinct answer. 1.03. What is the ratio of the Population growth (in %) in Guinea in 1972 to that in 1973?
Your answer should be very brief. 1.05. What is the ratio of the Population growth (in %) in Korea (Republic) in 1972 to that in 1973?
Keep it short and to the point. 1.04. What is the ratio of the Population growth (in %) in Oman in 1972 to that in 1973?
Provide a succinct answer. 0.99. What is the ratio of the Population growth (in %) in Bangladesh in 1972 to that in 1974?
Your answer should be compact. 0.79. What is the ratio of the Population growth (in %) in Guinea in 1972 to that in 1974?
Make the answer very short. 1.08. What is the ratio of the Population growth (in %) of Korea (Republic) in 1972 to that in 1974?
Your answer should be very brief. 1.07. What is the ratio of the Population growth (in %) of Oman in 1972 to that in 1974?
Your answer should be very brief. 0.96. What is the ratio of the Population growth (in %) in Bangladesh in 1972 to that in 1975?
Offer a very short reply. 0.54. What is the ratio of the Population growth (in %) in Guinea in 1972 to that in 1975?
Give a very brief answer. 1.11. What is the ratio of the Population growth (in %) in Korea (Republic) in 1972 to that in 1975?
Provide a succinct answer. 1.09. What is the ratio of the Population growth (in %) in Oman in 1972 to that in 1975?
Your response must be concise. 0.93. What is the ratio of the Population growth (in %) of Bangladesh in 1972 to that in 1976?
Offer a very short reply. 0.53. What is the ratio of the Population growth (in %) of Guinea in 1972 to that in 1976?
Offer a terse response. 1.13. What is the ratio of the Population growth (in %) of Korea (Republic) in 1972 to that in 1976?
Give a very brief answer. 1.03. What is the ratio of the Population growth (in %) in Oman in 1972 to that in 1976?
Keep it short and to the point. 0.91. What is the ratio of the Population growth (in %) in Bangladesh in 1972 to that in 1977?
Keep it short and to the point. 0.52. What is the ratio of the Population growth (in %) of Guinea in 1972 to that in 1977?
Provide a short and direct response. 1.14. What is the ratio of the Population growth (in %) of Korea (Republic) in 1972 to that in 1977?
Give a very brief answer. 1.03. What is the ratio of the Population growth (in %) of Oman in 1972 to that in 1977?
Provide a succinct answer. 0.9. What is the ratio of the Population growth (in %) in Bangladesh in 1973 to that in 1974?
Your answer should be compact. 0.77. What is the ratio of the Population growth (in %) in Guinea in 1973 to that in 1974?
Your answer should be very brief. 1.03. What is the ratio of the Population growth (in %) in Korea (Republic) in 1973 to that in 1974?
Ensure brevity in your answer.  1.03. What is the ratio of the Population growth (in %) in Oman in 1973 to that in 1974?
Provide a succinct answer. 0.97. What is the ratio of the Population growth (in %) in Bangladesh in 1973 to that in 1975?
Make the answer very short. 0.53. What is the ratio of the Population growth (in %) in Guinea in 1973 to that in 1975?
Give a very brief answer. 1.05. What is the ratio of the Population growth (in %) in Korea (Republic) in 1973 to that in 1975?
Keep it short and to the point. 1.05. What is the ratio of the Population growth (in %) in Oman in 1973 to that in 1975?
Offer a very short reply. 0.94. What is the ratio of the Population growth (in %) in Bangladesh in 1973 to that in 1976?
Offer a very short reply. 0.52. What is the ratio of the Population growth (in %) in Guinea in 1973 to that in 1976?
Ensure brevity in your answer.  1.07. What is the ratio of the Population growth (in %) of Korea (Republic) in 1973 to that in 1976?
Your answer should be compact. 0.99. What is the ratio of the Population growth (in %) of Oman in 1973 to that in 1976?
Provide a short and direct response. 0.92. What is the ratio of the Population growth (in %) of Bangladesh in 1973 to that in 1977?
Provide a succinct answer. 0.51. What is the ratio of the Population growth (in %) in Guinea in 1973 to that in 1977?
Provide a succinct answer. 1.09. What is the ratio of the Population growth (in %) of Oman in 1973 to that in 1977?
Offer a very short reply. 0.91. What is the ratio of the Population growth (in %) in Bangladesh in 1974 to that in 1975?
Offer a very short reply. 0.68. What is the ratio of the Population growth (in %) of Guinea in 1974 to that in 1975?
Your response must be concise. 1.02. What is the ratio of the Population growth (in %) in Korea (Republic) in 1974 to that in 1975?
Your response must be concise. 1.02. What is the ratio of the Population growth (in %) of Bangladesh in 1974 to that in 1976?
Your answer should be very brief. 0.67. What is the ratio of the Population growth (in %) in Guinea in 1974 to that in 1976?
Ensure brevity in your answer.  1.04. What is the ratio of the Population growth (in %) of Korea (Republic) in 1974 to that in 1976?
Your response must be concise. 0.97. What is the ratio of the Population growth (in %) in Oman in 1974 to that in 1976?
Offer a terse response. 0.95. What is the ratio of the Population growth (in %) of Bangladesh in 1974 to that in 1977?
Give a very brief answer. 0.66. What is the ratio of the Population growth (in %) of Guinea in 1974 to that in 1977?
Ensure brevity in your answer.  1.05. What is the ratio of the Population growth (in %) of Oman in 1974 to that in 1977?
Give a very brief answer. 0.94. What is the ratio of the Population growth (in %) of Bangladesh in 1975 to that in 1976?
Your response must be concise. 0.98. What is the ratio of the Population growth (in %) in Guinea in 1975 to that in 1976?
Provide a short and direct response. 1.02. What is the ratio of the Population growth (in %) in Korea (Republic) in 1975 to that in 1976?
Ensure brevity in your answer.  0.94. What is the ratio of the Population growth (in %) in Oman in 1975 to that in 1976?
Your answer should be very brief. 0.98. What is the ratio of the Population growth (in %) in Bangladesh in 1975 to that in 1977?
Offer a very short reply. 0.96. What is the ratio of the Population growth (in %) of Guinea in 1975 to that in 1977?
Provide a short and direct response. 1.03. What is the ratio of the Population growth (in %) of Korea (Republic) in 1975 to that in 1977?
Make the answer very short. 0.95. What is the ratio of the Population growth (in %) of Bangladesh in 1976 to that in 1977?
Your response must be concise. 0.99. What is the ratio of the Population growth (in %) in Guinea in 1976 to that in 1977?
Give a very brief answer. 1.01. What is the difference between the highest and the second highest Population growth (in %) of Bangladesh?
Your answer should be very brief. 0.16. What is the difference between the highest and the second highest Population growth (in %) of Guinea?
Offer a terse response. 0.31. What is the difference between the highest and the second highest Population growth (in %) in Korea (Republic)?
Offer a terse response. 1.36. What is the difference between the highest and the second highest Population growth (in %) in Oman?
Ensure brevity in your answer.  0.12. What is the difference between the highest and the lowest Population growth (in %) of Bangladesh?
Provide a short and direct response. 5.38. What is the difference between the highest and the lowest Population growth (in %) in Guinea?
Your response must be concise. 1.18. What is the difference between the highest and the lowest Population growth (in %) of Korea (Republic)?
Give a very brief answer. 2.33. What is the difference between the highest and the lowest Population growth (in %) in Oman?
Offer a very short reply. 1.11. 